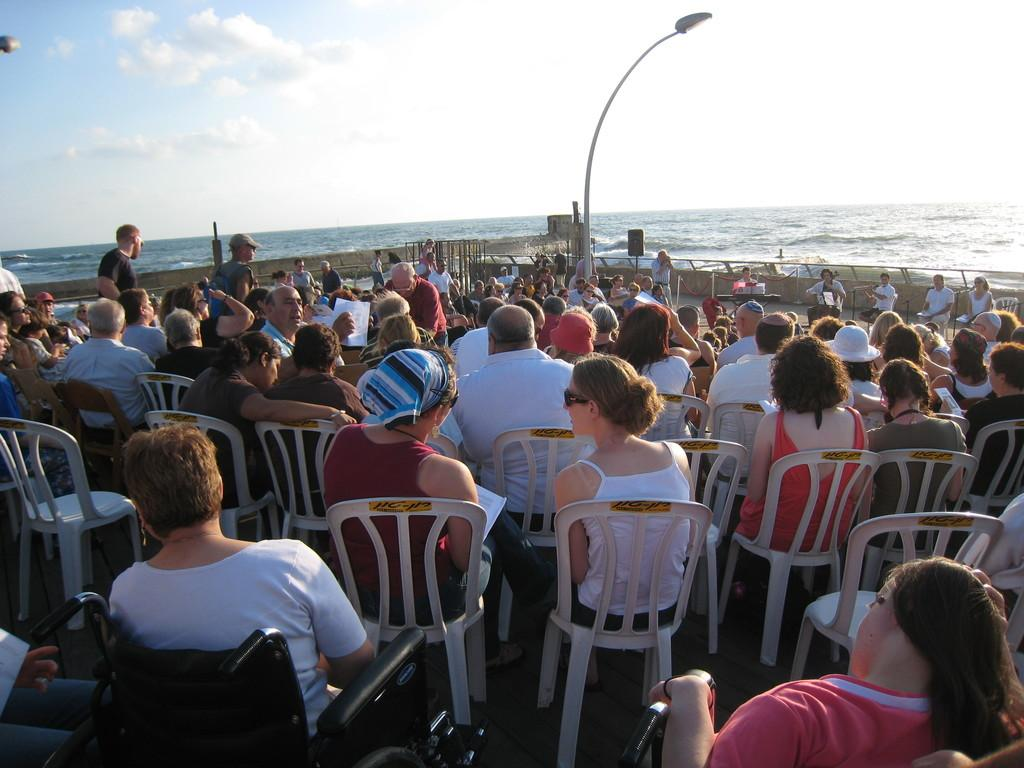What is the main subject of the image? There are many people seated on white chairs in the image. Can you describe the person at the front? A person is sitting in a wheelchair at the front. What is the purpose of the light pole in the image? The light pole is likely for illumination purposes. What can be seen in the background of the image? There is water visible in the image, and the sky is visible at the top of the image. What type of trail can be seen in the image? There is no trail visible in the image. Is there any sleet falling in the image? There is no mention of sleet or any weather conditions in the image. 